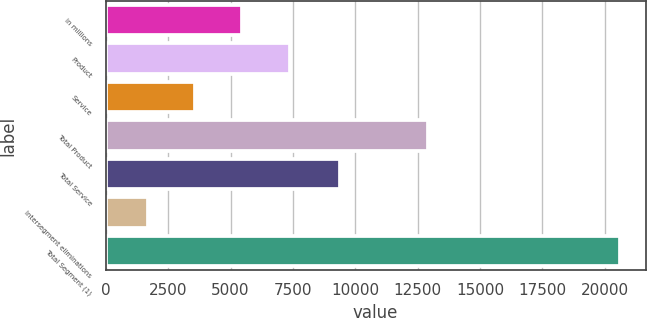Convert chart to OTSL. <chart><loc_0><loc_0><loc_500><loc_500><bar_chart><fcel>in millions<fcel>Product<fcel>Service<fcel>Total Product<fcel>Total Service<fcel>Intersegment eliminations<fcel>Total Segment (1)<nl><fcel>5479.6<fcel>7370.4<fcel>3588.8<fcel>12896<fcel>9408<fcel>1698<fcel>20606<nl></chart> 